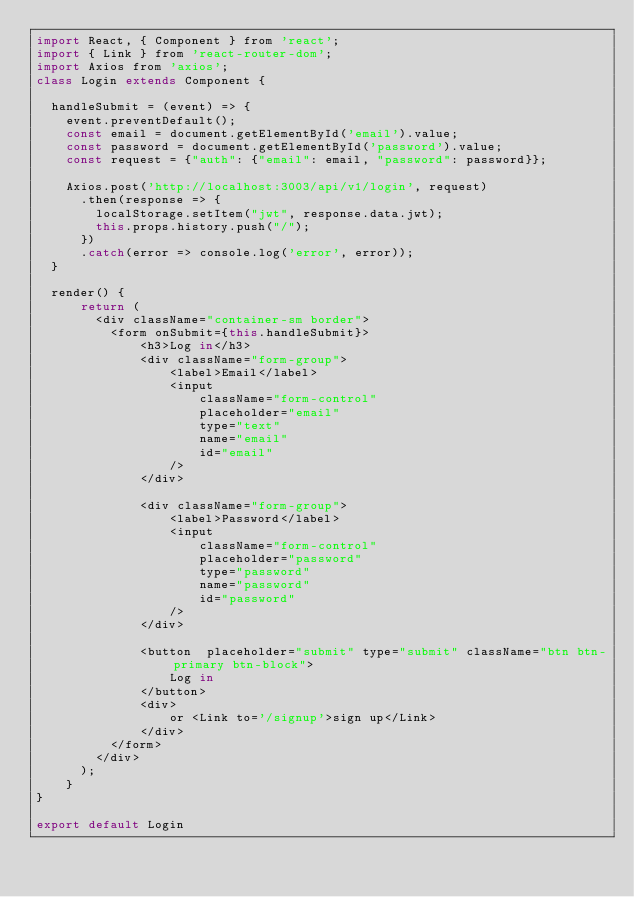Convert code to text. <code><loc_0><loc_0><loc_500><loc_500><_JavaScript_>import React, { Component } from 'react';
import { Link } from 'react-router-dom';
import Axios from 'axios';
class Login extends Component {

  handleSubmit = (event) => {
    event.preventDefault();
    const email = document.getElementById('email').value;
    const password = document.getElementById('password').value;
    const request = {"auth": {"email": email, "password": password}};

    Axios.post('http://localhost:3003/api/v1/login', request)
      .then(response => {
        localStorage.setItem("jwt", response.data.jwt);
        this.props.history.push("/");
      })
      .catch(error => console.log('error', error));
  }      

  render() {    
      return (
        <div className="container-sm border">         
          <form onSubmit={this.handleSubmit}>
              <h3>Log in</h3>
              <div className="form-group">
                  <label>Email</label>
                  <input
                      className="form-control"
                      placeholder="email"
                      type="text"
                      name="email"
                      id="email"
                  />
              </div>

              <div className="form-group">
                  <label>Password</label>
                  <input
                      className="form-control"
                      placeholder="password"
                      type="password"
                      name="password"
                      id="password"
                  />   
              </div>

              <button  placeholder="submit" type="submit" className="btn btn-primary btn-block">
                  Log in
              </button>          
              <div>
                  or <Link to='/signup'>sign up</Link>
              </div>                  
          </form>  
        </div>  
      );
    }
}

export default Login
</code> 